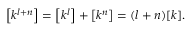<formula> <loc_0><loc_0><loc_500><loc_500>\left [ k ^ { l + n } \right ] = \left [ k ^ { l } \right ] + \left [ k ^ { n } \right ] = ( l + n ) [ k ] .</formula> 